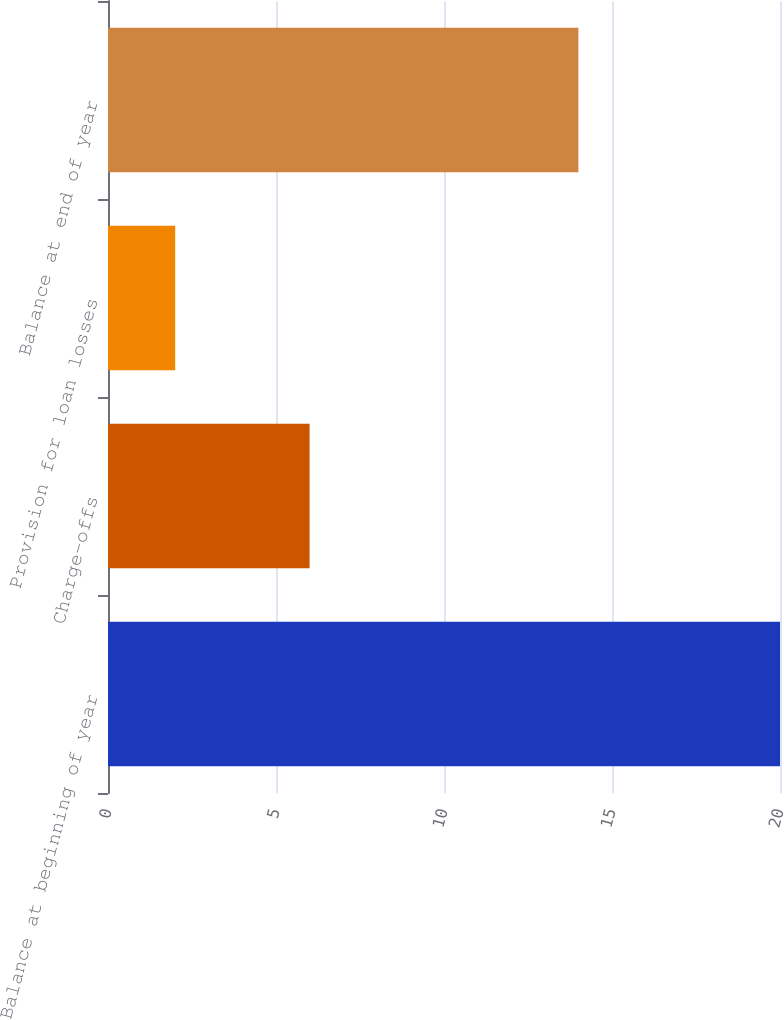Convert chart. <chart><loc_0><loc_0><loc_500><loc_500><bar_chart><fcel>Balance at beginning of year<fcel>Charge-offs<fcel>Provision for loan losses<fcel>Balance at end of year<nl><fcel>20<fcel>6<fcel>2<fcel>14<nl></chart> 